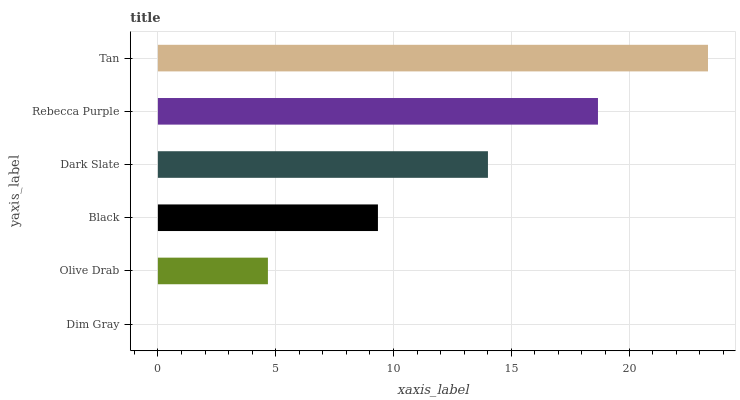Is Dim Gray the minimum?
Answer yes or no. Yes. Is Tan the maximum?
Answer yes or no. Yes. Is Olive Drab the minimum?
Answer yes or no. No. Is Olive Drab the maximum?
Answer yes or no. No. Is Olive Drab greater than Dim Gray?
Answer yes or no. Yes. Is Dim Gray less than Olive Drab?
Answer yes or no. Yes. Is Dim Gray greater than Olive Drab?
Answer yes or no. No. Is Olive Drab less than Dim Gray?
Answer yes or no. No. Is Dark Slate the high median?
Answer yes or no. Yes. Is Black the low median?
Answer yes or no. Yes. Is Dim Gray the high median?
Answer yes or no. No. Is Olive Drab the low median?
Answer yes or no. No. 